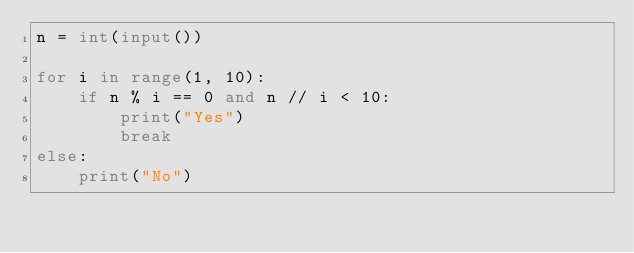<code> <loc_0><loc_0><loc_500><loc_500><_Python_>n = int(input())

for i in range(1, 10):
    if n % i == 0 and n // i < 10:
        print("Yes")
        break
else:
    print("No")</code> 